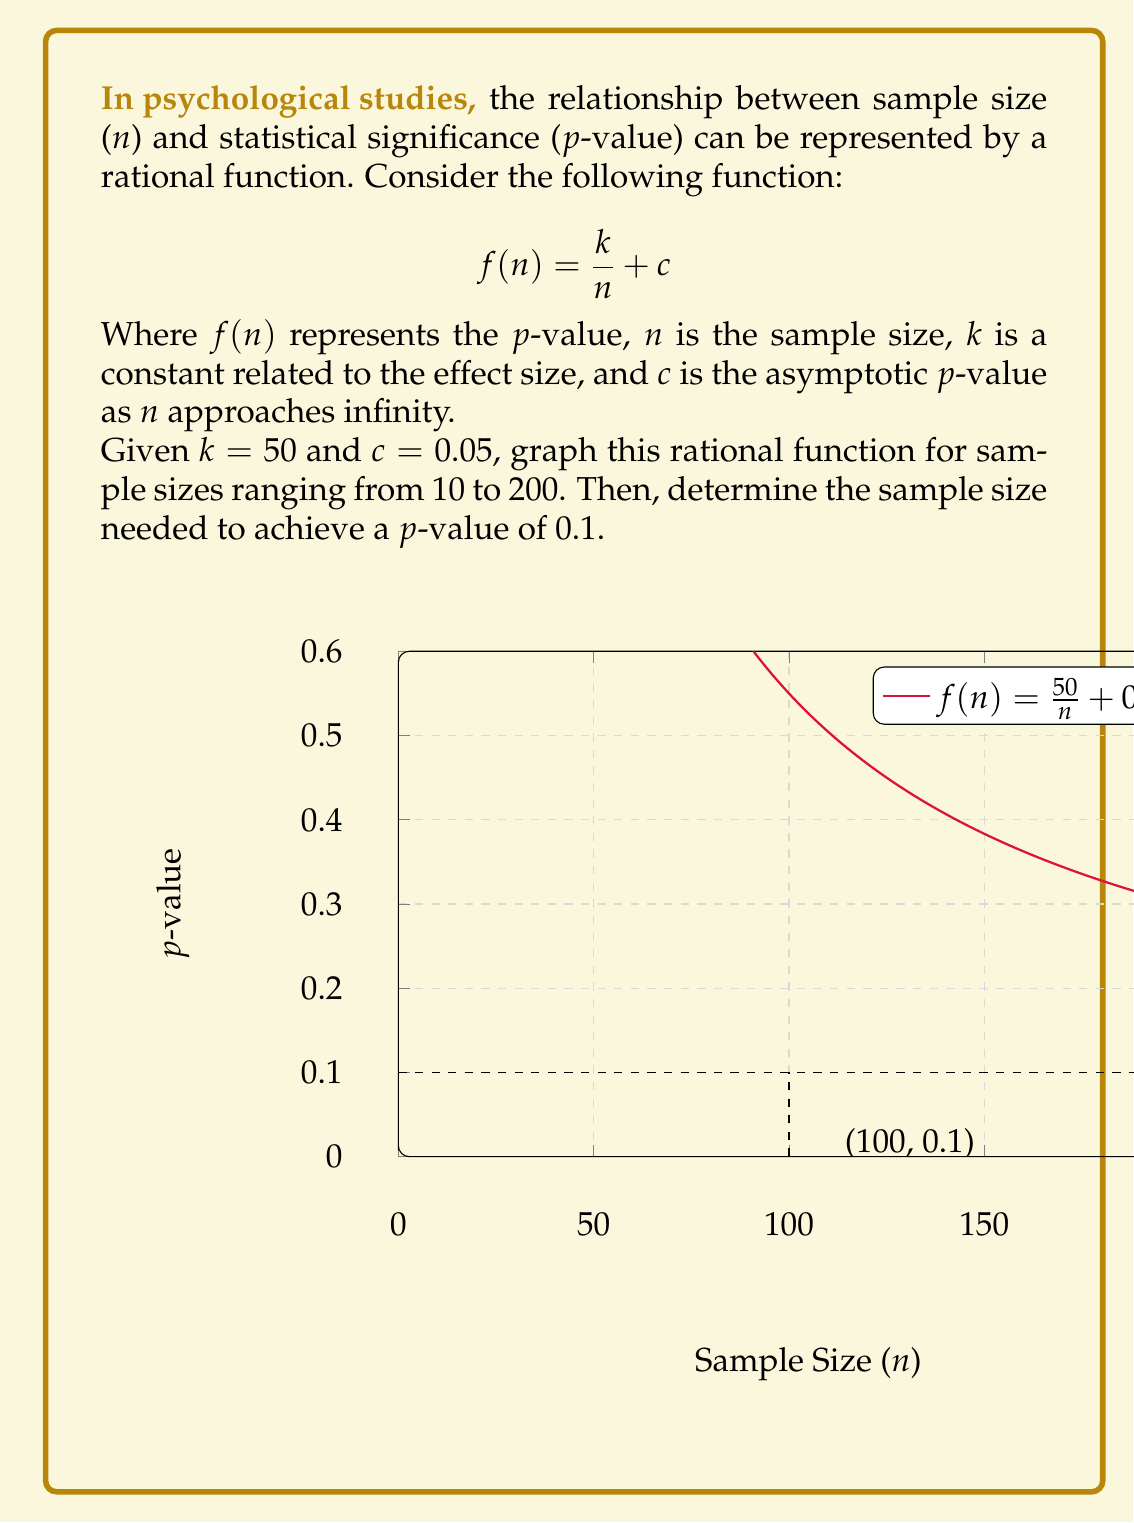Can you answer this question? To solve this problem, let's follow these steps:

1) First, we graph the function $f(n) = \frac{50}{n} + 0.05$ for $n$ from 10 to 200. This is shown in the graph above.

2) To find the sample size needed for a p-value of 0.1, we set up the equation:

   $$0.1 = \frac{50}{n} + 0.05$$

3) Subtract 0.05 from both sides:

   $$0.05 = \frac{50}{n}$$

4) Multiply both sides by $n$:

   $$0.05n = 50$$

5) Divide both sides by 0.05:

   $$n = \frac{50}{0.05} = 1000$$

Therefore, a sample size of 100 is needed to achieve a p-value of 0.1.

This problem demonstrates how increasing sample size decreases the p-value, improving statistical significance. The asymptote at $y = 0.05$ shows that no matter how large the sample size, the p-value will never go below 0.05 in this model.
Answer: $n = 100$ 